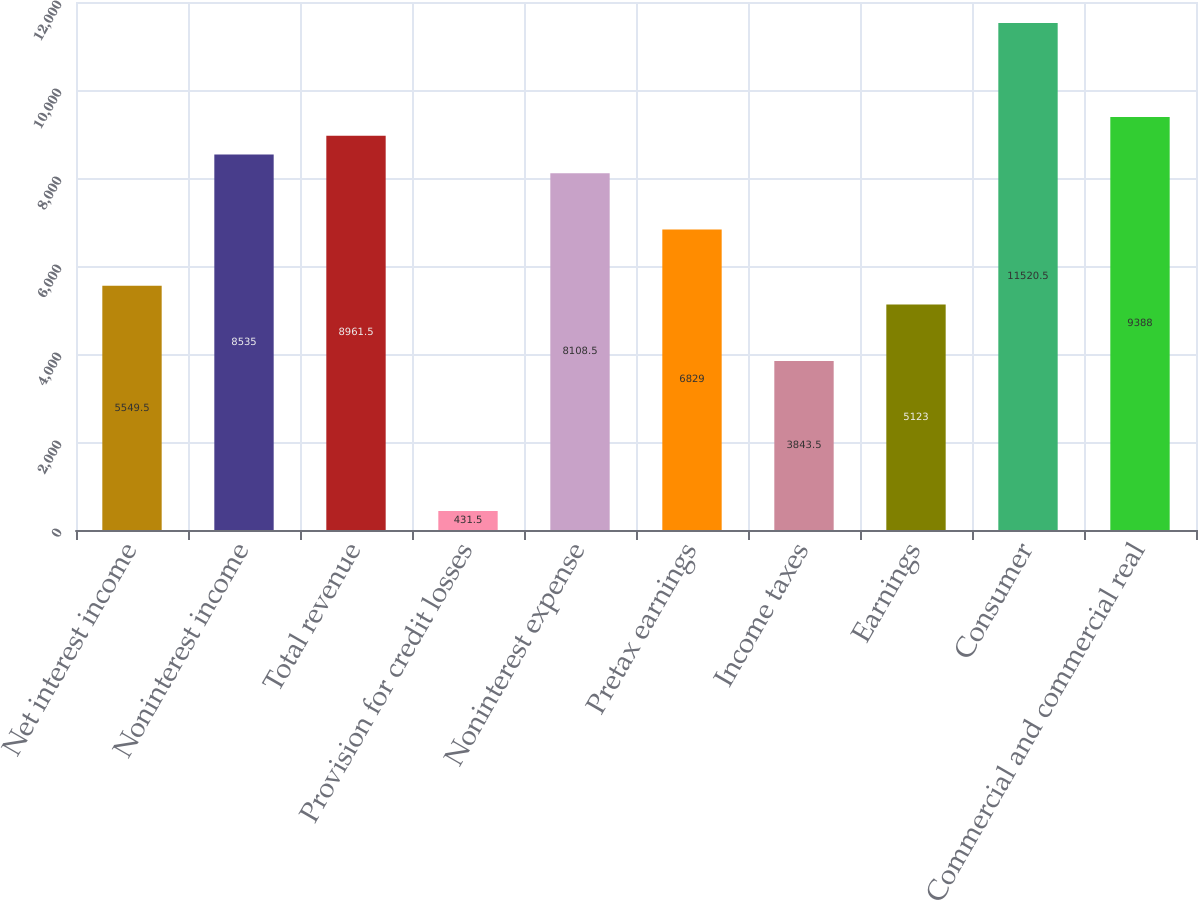<chart> <loc_0><loc_0><loc_500><loc_500><bar_chart><fcel>Net interest income<fcel>Noninterest income<fcel>Total revenue<fcel>Provision for credit losses<fcel>Noninterest expense<fcel>Pretax earnings<fcel>Income taxes<fcel>Earnings<fcel>Consumer<fcel>Commercial and commercial real<nl><fcel>5549.5<fcel>8535<fcel>8961.5<fcel>431.5<fcel>8108.5<fcel>6829<fcel>3843.5<fcel>5123<fcel>11520.5<fcel>9388<nl></chart> 